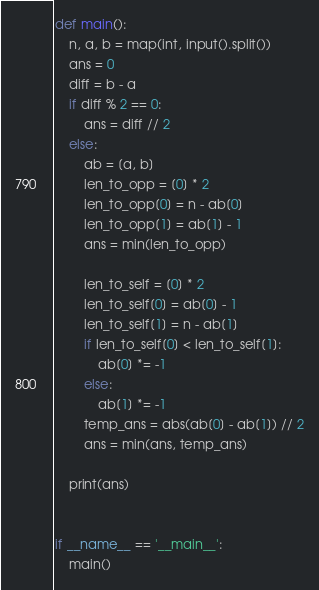<code> <loc_0><loc_0><loc_500><loc_500><_Python_>def main():
    n, a, b = map(int, input().split())
    ans = 0
    diff = b - a
    if diff % 2 == 0:
        ans = diff // 2
    else:
        ab = [a, b]
        len_to_opp = [0] * 2
        len_to_opp[0] = n - ab[0]
        len_to_opp[1] = ab[1] - 1
        ans = min(len_to_opp)

        len_to_self = [0] * 2
        len_to_self[0] = ab[0] - 1
        len_to_self[1] = n - ab[1]
        if len_to_self[0] < len_to_self[1]:
            ab[0] *= -1
        else:
            ab[1] *= -1
        temp_ans = abs(ab[0] - ab[1]) // 2
        ans = min(ans, temp_ans)

    print(ans)


if __name__ == '__main__':
    main()
</code> 